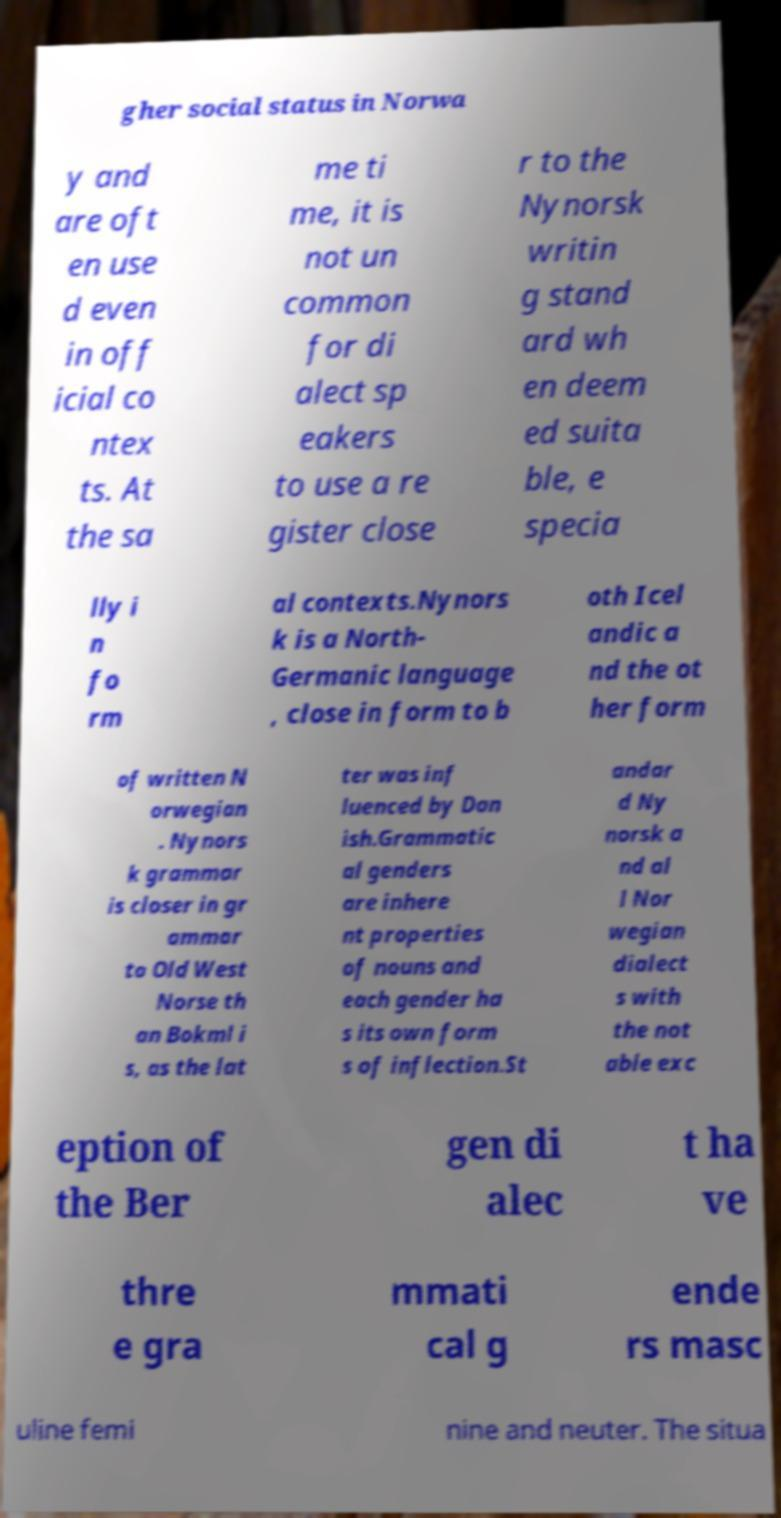Could you assist in decoding the text presented in this image and type it out clearly? gher social status in Norwa y and are oft en use d even in off icial co ntex ts. At the sa me ti me, it is not un common for di alect sp eakers to use a re gister close r to the Nynorsk writin g stand ard wh en deem ed suita ble, e specia lly i n fo rm al contexts.Nynors k is a North- Germanic language , close in form to b oth Icel andic a nd the ot her form of written N orwegian . Nynors k grammar is closer in gr ammar to Old West Norse th an Bokml i s, as the lat ter was inf luenced by Dan ish.Grammatic al genders are inhere nt properties of nouns and each gender ha s its own form s of inflection.St andar d Ny norsk a nd al l Nor wegian dialect s with the not able exc eption of the Ber gen di alec t ha ve thre e gra mmati cal g ende rs masc uline femi nine and neuter. The situa 